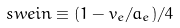Convert formula to latex. <formula><loc_0><loc_0><loc_500><loc_500>\ s w e i n \equiv ( 1 - v _ { e } / a _ { e } ) / 4</formula> 